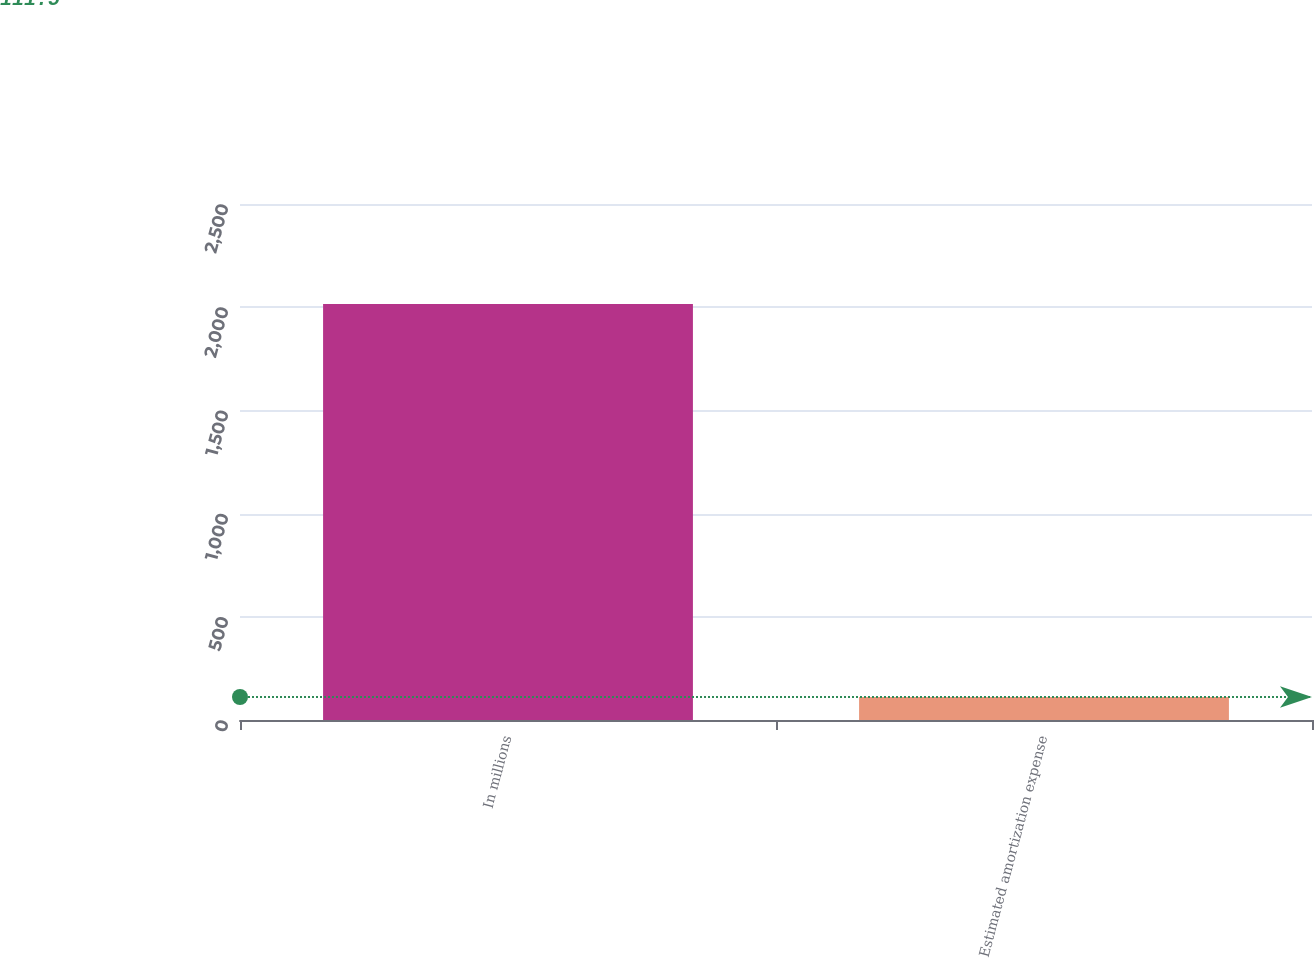<chart> <loc_0><loc_0><loc_500><loc_500><bar_chart><fcel>In millions<fcel>Estimated amortization expense<nl><fcel>2015<fcel>111.5<nl></chart> 